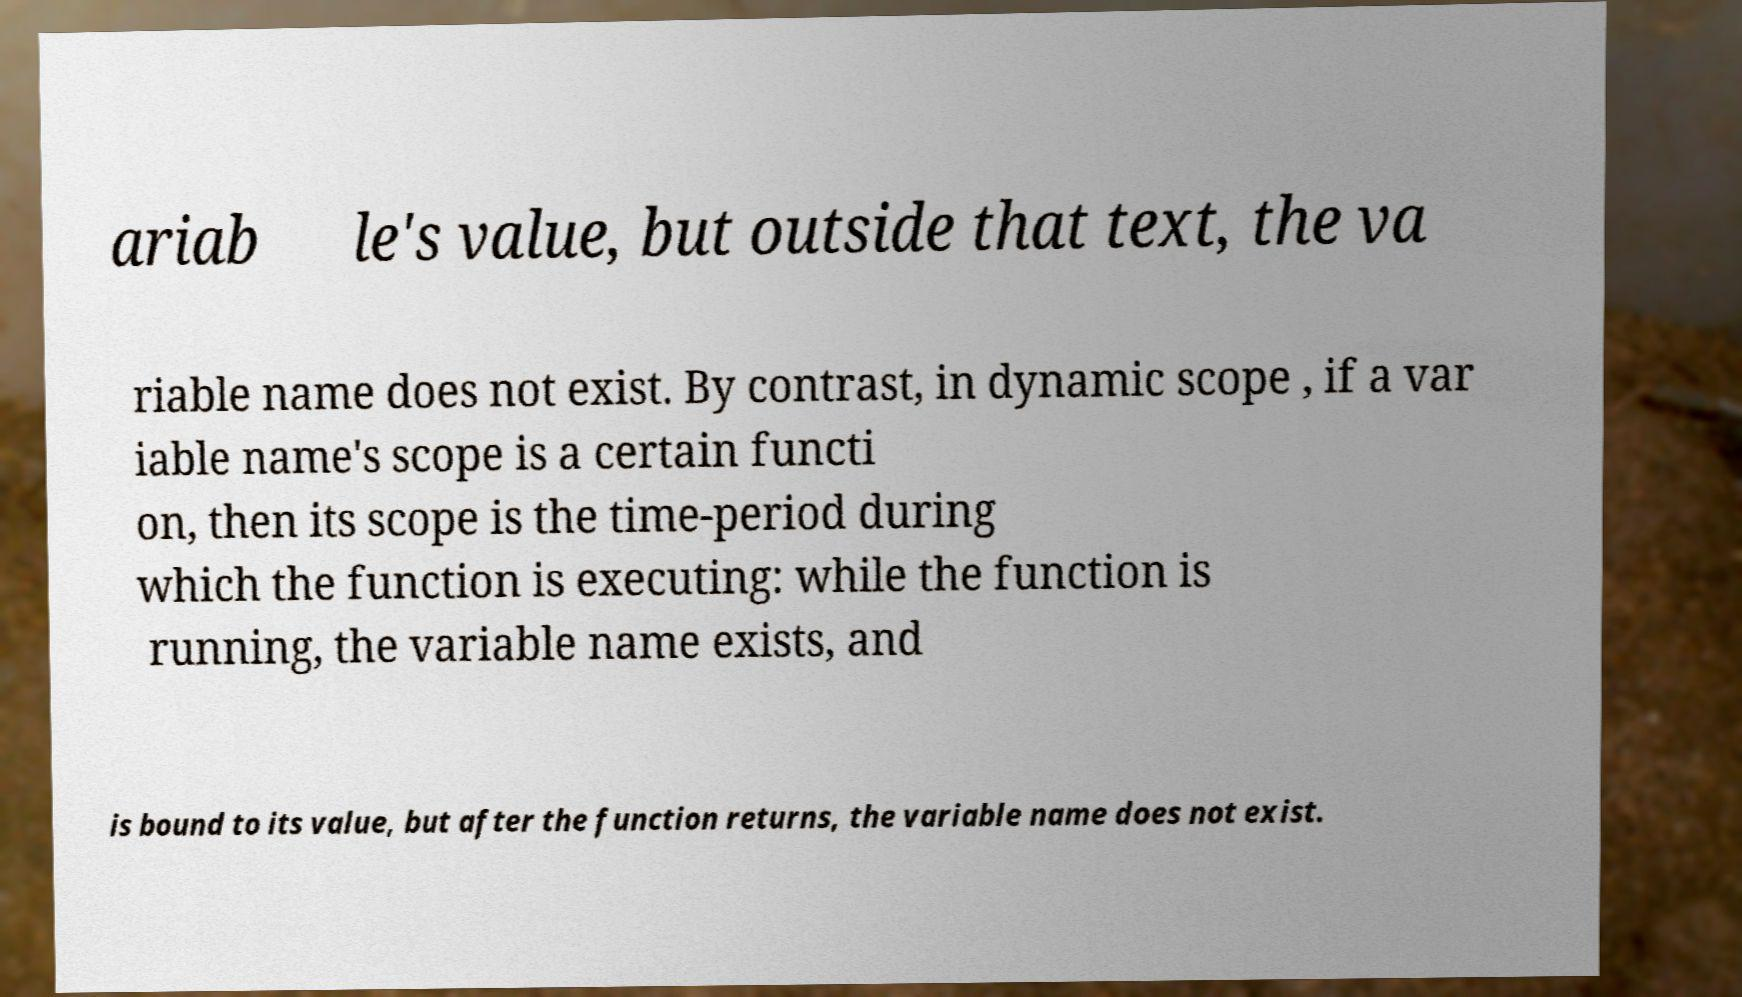What messages or text are displayed in this image? I need them in a readable, typed format. ariab le's value, but outside that text, the va riable name does not exist. By contrast, in dynamic scope , if a var iable name's scope is a certain functi on, then its scope is the time-period during which the function is executing: while the function is running, the variable name exists, and is bound to its value, but after the function returns, the variable name does not exist. 